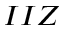<formula> <loc_0><loc_0><loc_500><loc_500>I I Z</formula> 